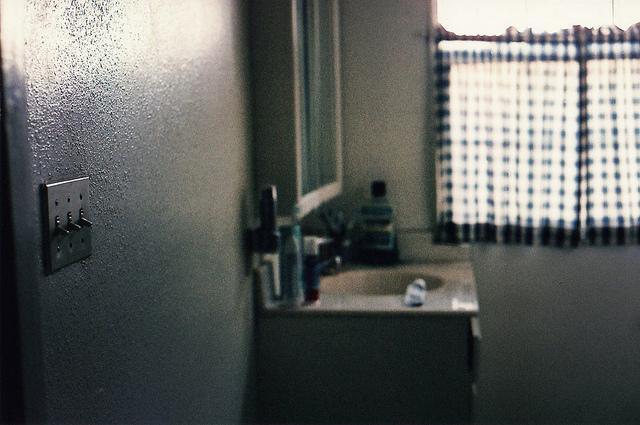How many yellow taxi cars are in this image?
Give a very brief answer. 0. 